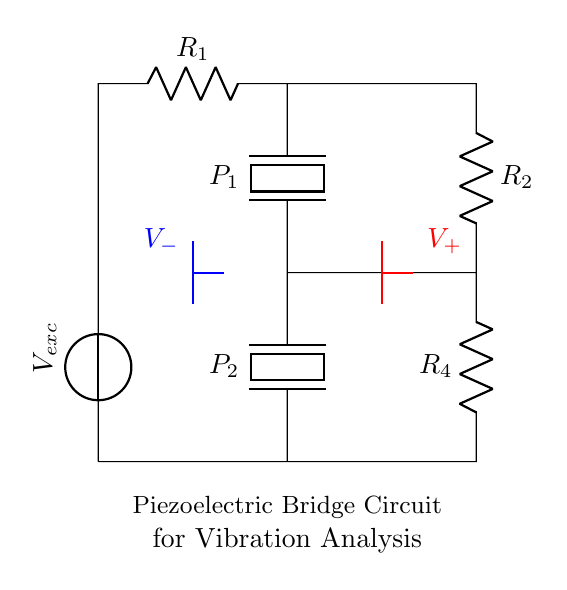What is the primary type of circuit shown? The circuit is a bridge circuit, specifically designed to analyze vibrations with piezoelectric elements. This is identifiable by its structure, which uses a network of resistors and piezoelectric sensors arranged in a way that forms a balanced circuit.
Answer: Bridge circuit What components are used in the circuit? The circuit comprises two resistors (R1 and R2), two piezoelectric elements (P1 and P2), and an excitation voltage source (V_exc). Identifying the labels on the components in the diagram allows us to list them accurately.
Answer: R1, R2, P1, P2, V_exc What is the role of the piezoelectric components? The piezoelectric components are used to convert mechanical vibrations into electrical signals, essential for the vibration analysis intended in this circuit. This function arises from their ability to generate voltage when subjected to stress or strain.
Answer: Convert vibrations to electrical signals What is the function of the excitation voltage source? The excitation voltage source, labeled V_exc, provides the necessary voltage to stimulate the piezoelectric elements, enabling them to respond to vibrations. This voltage is crucial for activating the sensors and obtaining measurable output.
Answer: Stimulates piezoelectric elements What do the labels V+ and V- indicate? V+ and V- indicate the positive and negative output voltage terminals of the bridge circuit, respectively. They represent the potential difference that results from the differential outputs of the piezoelectric sensors when they detect vibrations, allowing for measurement and analysis.
Answer: Positive and negative output voltages How many resistors are in the circuit? There are two resistors in the circuit, identified as R1 and R2, positioned in the upper and lower sections of the bridge configuration. Counting the labeled components in the diagram confirms this.
Answer: 2 What type of analysis is this circuit used for? The circuit is used for vibration analysis, specifically in the context of sculpture conservation. This application is inherently linked to the use of piezoelectric sensors for monitoring the structural integrity of sculptures under vibrational forces.
Answer: Vibration analysis 